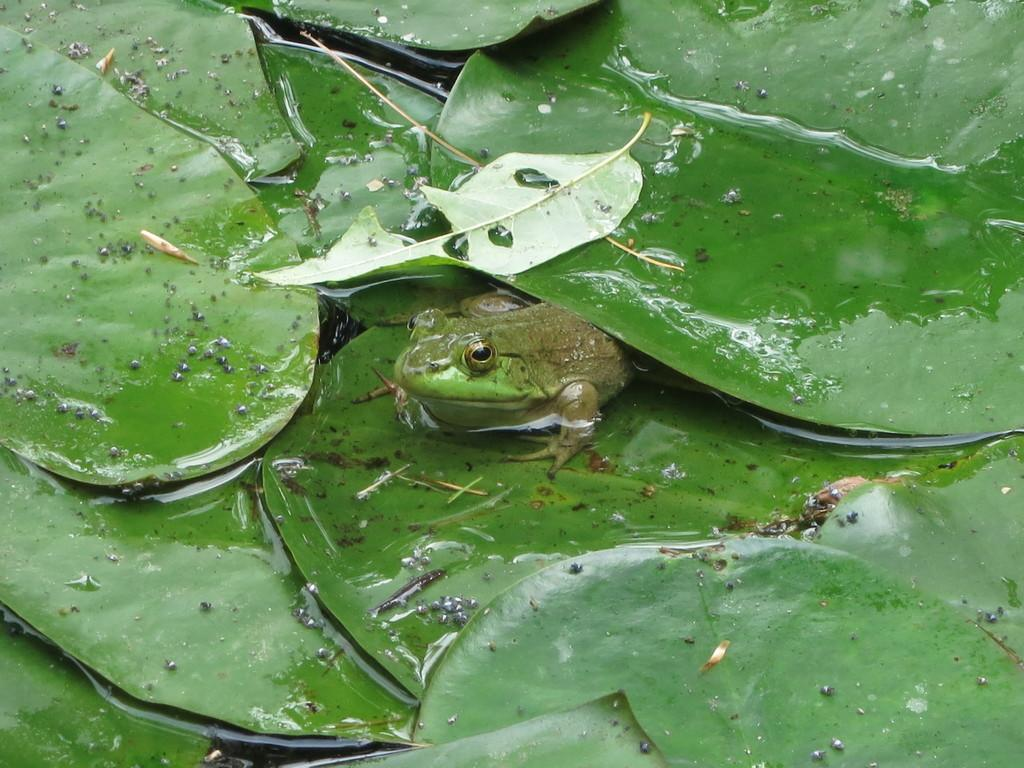What type of vegetation can be seen in the image? There are leaves in the image. What animal is located in the middle of the image? There is a frog in the middle of the image. What type of society is depicted in the image? There is no society depicted in the image; it features leaves and a frog. What time of day is it in the image? The time of day is not mentioned or depicted in the image. 